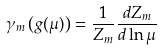<formula> <loc_0><loc_0><loc_500><loc_500>\gamma _ { m } \left ( g ( \mu ) \right ) = \frac { 1 } { Z _ { m } } \frac { d Z _ { m } } { d \ln \mu }</formula> 